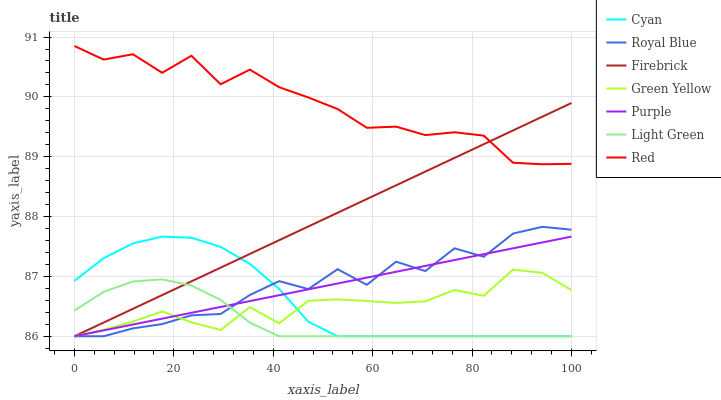Does Light Green have the minimum area under the curve?
Answer yes or no. Yes. Does Red have the maximum area under the curve?
Answer yes or no. Yes. Does Firebrick have the minimum area under the curve?
Answer yes or no. No. Does Firebrick have the maximum area under the curve?
Answer yes or no. No. Is Purple the smoothest?
Answer yes or no. Yes. Is Royal Blue the roughest?
Answer yes or no. Yes. Is Firebrick the smoothest?
Answer yes or no. No. Is Firebrick the roughest?
Answer yes or no. No. Does Red have the lowest value?
Answer yes or no. No. Does Red have the highest value?
Answer yes or no. Yes. Does Firebrick have the highest value?
Answer yes or no. No. Is Purple less than Red?
Answer yes or no. Yes. Is Red greater than Light Green?
Answer yes or no. Yes. Does Light Green intersect Purple?
Answer yes or no. Yes. Is Light Green less than Purple?
Answer yes or no. No. Is Light Green greater than Purple?
Answer yes or no. No. Does Purple intersect Red?
Answer yes or no. No. 